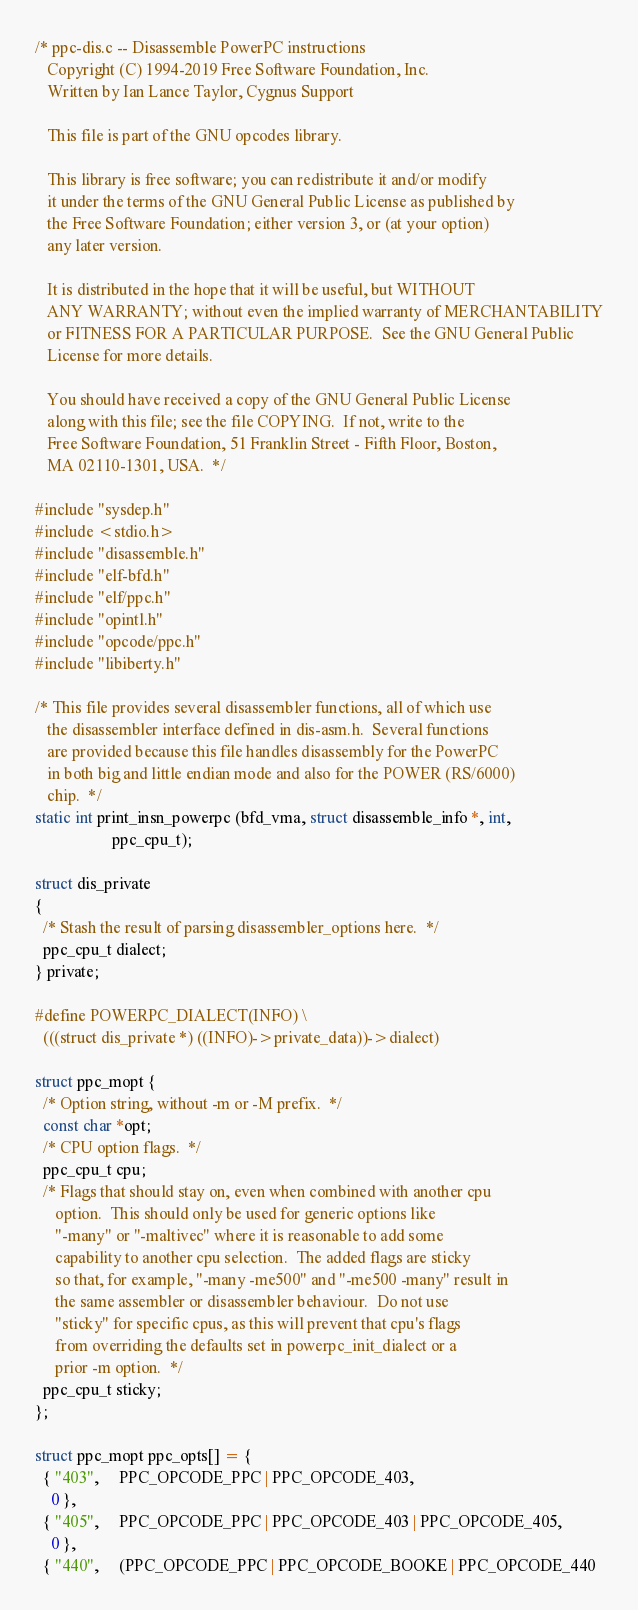Convert code to text. <code><loc_0><loc_0><loc_500><loc_500><_C_>/* ppc-dis.c -- Disassemble PowerPC instructions
   Copyright (C) 1994-2019 Free Software Foundation, Inc.
   Written by Ian Lance Taylor, Cygnus Support

   This file is part of the GNU opcodes library.

   This library is free software; you can redistribute it and/or modify
   it under the terms of the GNU General Public License as published by
   the Free Software Foundation; either version 3, or (at your option)
   any later version.

   It is distributed in the hope that it will be useful, but WITHOUT
   ANY WARRANTY; without even the implied warranty of MERCHANTABILITY
   or FITNESS FOR A PARTICULAR PURPOSE.  See the GNU General Public
   License for more details.

   You should have received a copy of the GNU General Public License
   along with this file; see the file COPYING.  If not, write to the
   Free Software Foundation, 51 Franklin Street - Fifth Floor, Boston,
   MA 02110-1301, USA.  */

#include "sysdep.h"
#include <stdio.h>
#include "disassemble.h"
#include "elf-bfd.h"
#include "elf/ppc.h"
#include "opintl.h"
#include "opcode/ppc.h"
#include "libiberty.h"

/* This file provides several disassembler functions, all of which use
   the disassembler interface defined in dis-asm.h.  Several functions
   are provided because this file handles disassembly for the PowerPC
   in both big and little endian mode and also for the POWER (RS/6000)
   chip.  */
static int print_insn_powerpc (bfd_vma, struct disassemble_info *, int,
			       ppc_cpu_t);

struct dis_private
{
  /* Stash the result of parsing disassembler_options here.  */
  ppc_cpu_t dialect;
} private;

#define POWERPC_DIALECT(INFO) \
  (((struct dis_private *) ((INFO)->private_data))->dialect)

struct ppc_mopt {
  /* Option string, without -m or -M prefix.  */
  const char *opt;
  /* CPU option flags.  */
  ppc_cpu_t cpu;
  /* Flags that should stay on, even when combined with another cpu
     option.  This should only be used for generic options like
     "-many" or "-maltivec" where it is reasonable to add some
     capability to another cpu selection.  The added flags are sticky
     so that, for example, "-many -me500" and "-me500 -many" result in
     the same assembler or disassembler behaviour.  Do not use
     "sticky" for specific cpus, as this will prevent that cpu's flags
     from overriding the defaults set in powerpc_init_dialect or a
     prior -m option.  */
  ppc_cpu_t sticky;
};

struct ppc_mopt ppc_opts[] = {
  { "403",     PPC_OPCODE_PPC | PPC_OPCODE_403,
    0 },
  { "405",     PPC_OPCODE_PPC | PPC_OPCODE_403 | PPC_OPCODE_405,
    0 },
  { "440",     (PPC_OPCODE_PPC | PPC_OPCODE_BOOKE | PPC_OPCODE_440</code> 